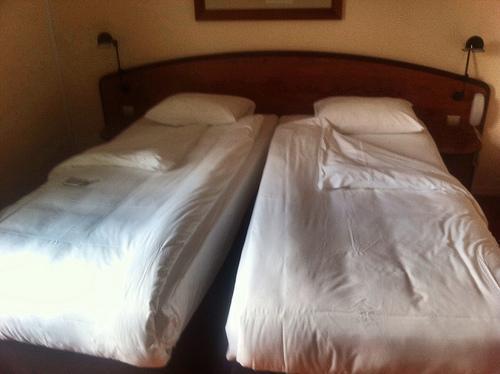How many pillows are there?
Give a very brief answer. 2. 